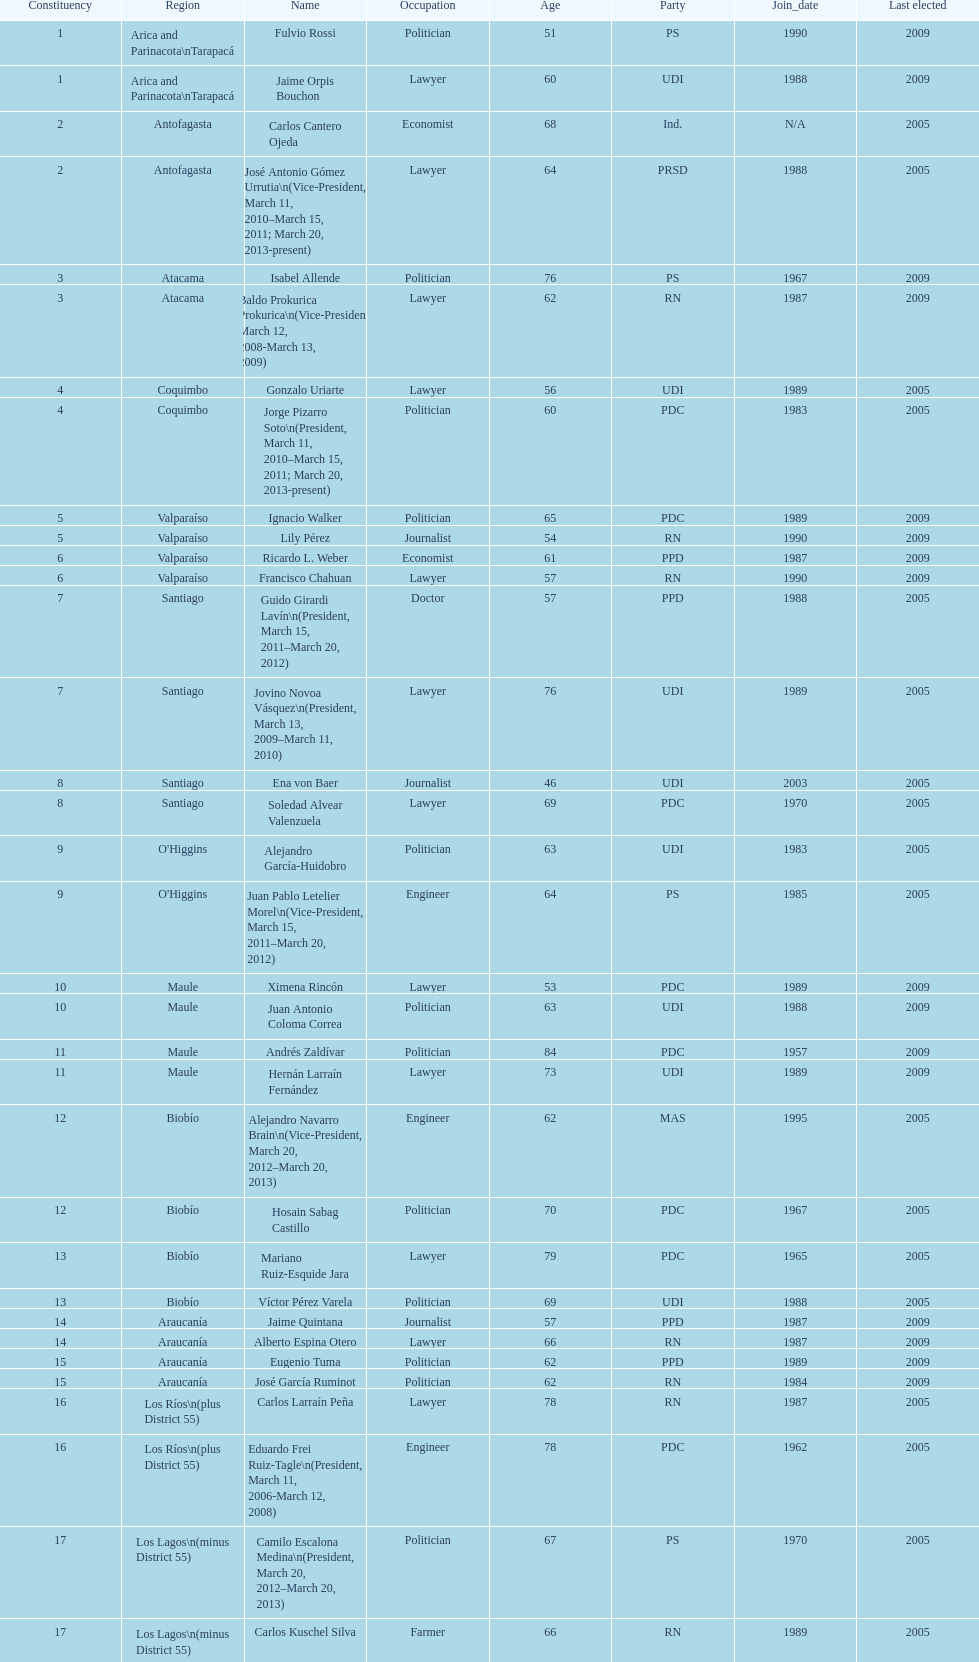What is the difference in years between constiuency 1 and 2? 4 years. 